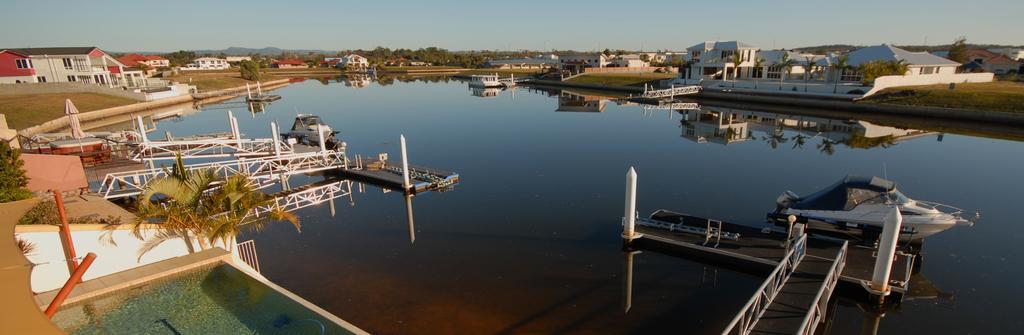Could you give a brief overview of what you see in this image? This image consists of water. In which we can see the boats. On the left and right, there are buildings along with the trees. At the top, there is sky. 